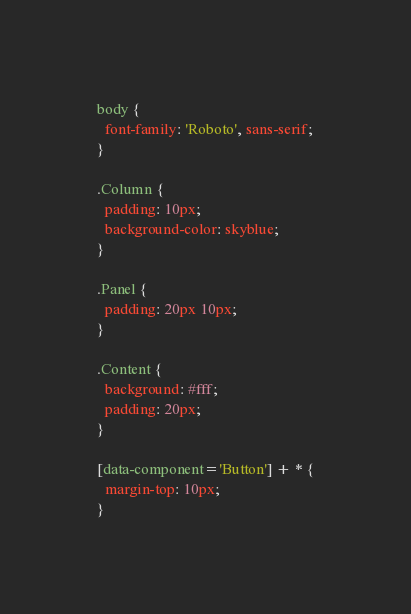<code> <loc_0><loc_0><loc_500><loc_500><_CSS_>body {
  font-family: 'Roboto', sans-serif;
}

.Column {
  padding: 10px;
  background-color: skyblue;
}

.Panel {
  padding: 20px 10px;
}

.Content {
  background: #fff;
  padding: 20px;
}

[data-component='Button'] + * {
  margin-top: 10px;
}
</code> 